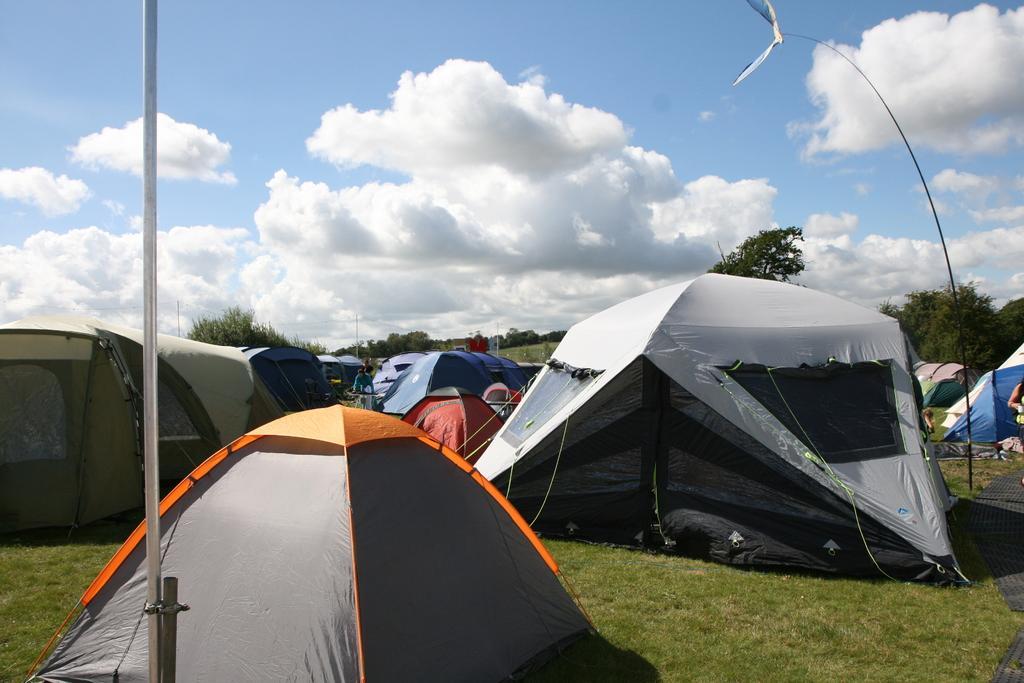Please provide a concise description of this image. This image is taken outdoors. At the top of the image there is a sky with clouds. In the background there are a few trees and plants. At the bottom of the image there is a ground with grass on it. In the middle of the image there are a few tents on the ground and there is a pole. 